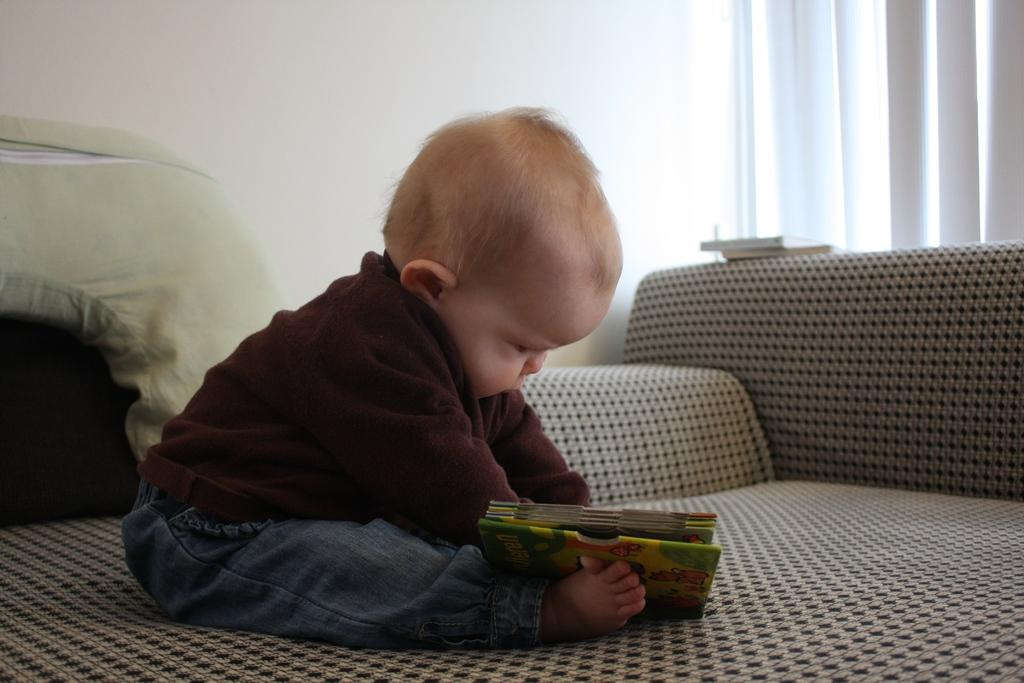What is the main subject of the image? There is a baby in the image. What is the baby wearing? The baby is wearing a maroon jacket and pants. Where is the baby sitting? The baby is sitting on a bed. What is the baby holding? The baby is holding a book in his hand. What can be seen behind the bed? There is a curtain behind the bed. Can you see any fairies in the image? No, there are no fairies present in the image. 